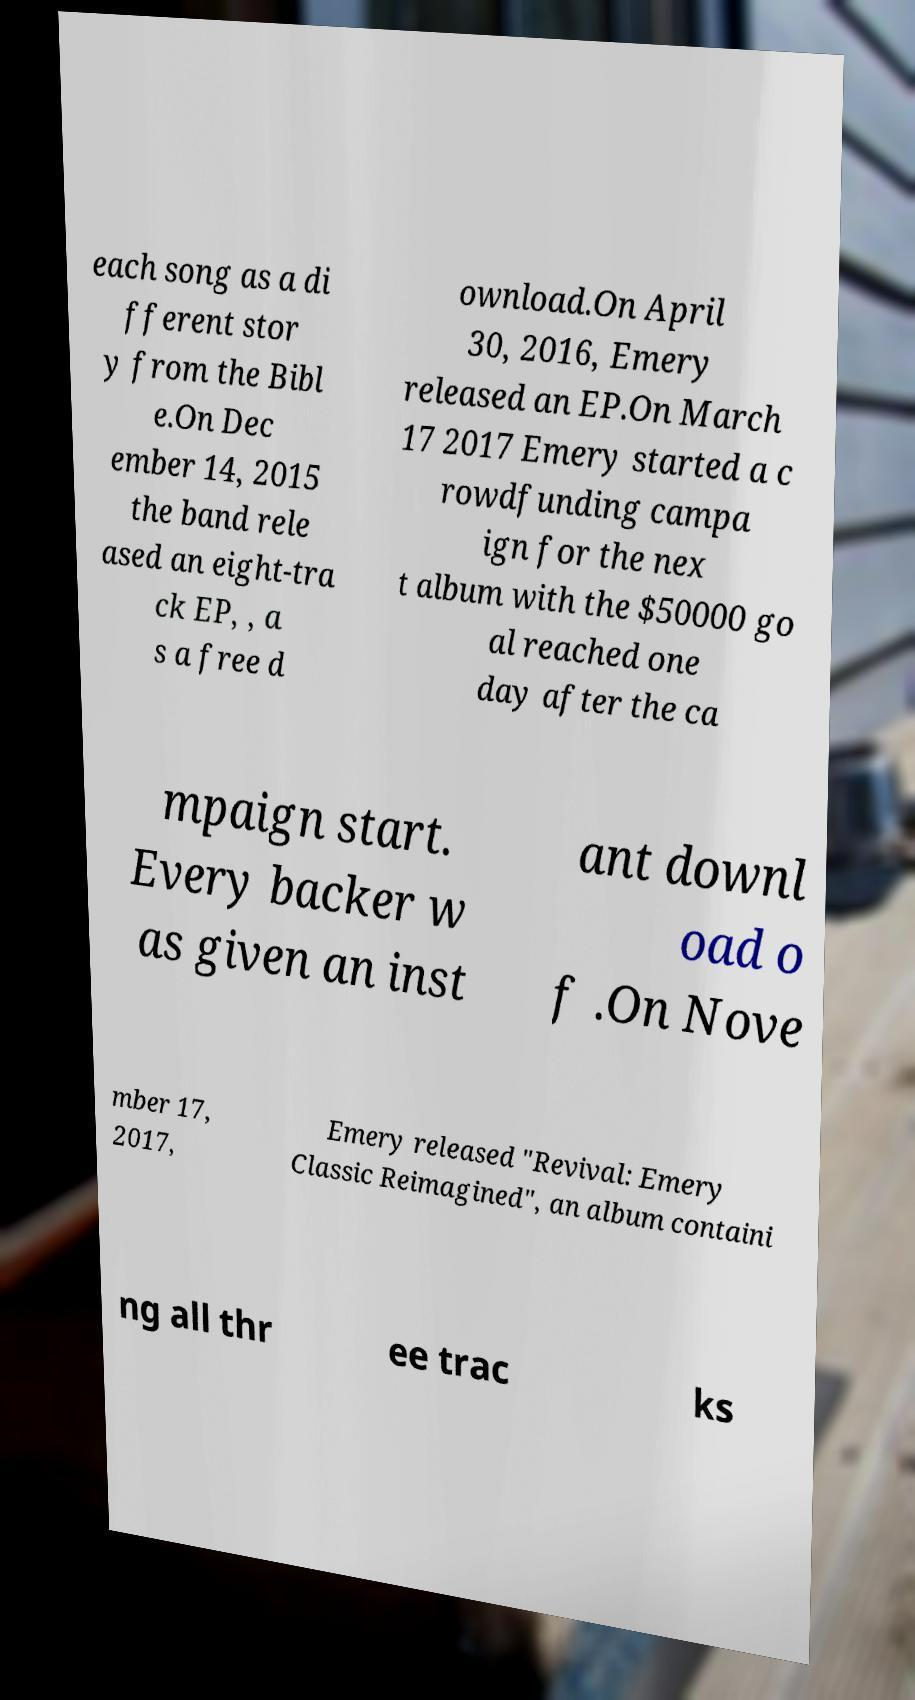Could you extract and type out the text from this image? each song as a di fferent stor y from the Bibl e.On Dec ember 14, 2015 the band rele ased an eight-tra ck EP, , a s a free d ownload.On April 30, 2016, Emery released an EP.On March 17 2017 Emery started a c rowdfunding campa ign for the nex t album with the $50000 go al reached one day after the ca mpaign start. Every backer w as given an inst ant downl oad o f .On Nove mber 17, 2017, Emery released "Revival: Emery Classic Reimagined", an album containi ng all thr ee trac ks 